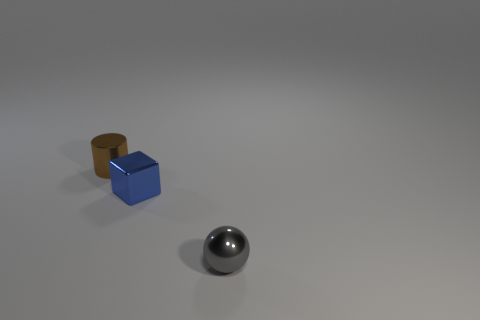Is there a tiny gray sphere behind the small thing to the left of the blue thing?
Offer a very short reply. No. Is the small gray metallic object the same shape as the brown object?
Provide a succinct answer. No. What is the shape of the gray object that is made of the same material as the blue object?
Your answer should be compact. Sphere. Does the shiny object behind the small blue thing have the same size as the metallic object right of the tiny blue block?
Ensure brevity in your answer.  Yes. Is the number of brown cylinders that are in front of the small cylinder greater than the number of gray spheres that are left of the tiny gray metal thing?
Provide a short and direct response. No. How many other objects are there of the same color as the small shiny cylinder?
Keep it short and to the point. 0. Does the small metallic sphere have the same color as the small object that is to the left of the blue shiny thing?
Make the answer very short. No. What number of cubes are left of the object in front of the small shiny block?
Your answer should be very brief. 1. Are there any other things that are made of the same material as the brown cylinder?
Provide a short and direct response. Yes. There is a thing that is both on the right side of the brown metallic object and behind the gray metal object; what is its material?
Your answer should be compact. Metal. 